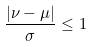<formula> <loc_0><loc_0><loc_500><loc_500>\frac { | \nu - \mu | } { \sigma } \leq 1</formula> 